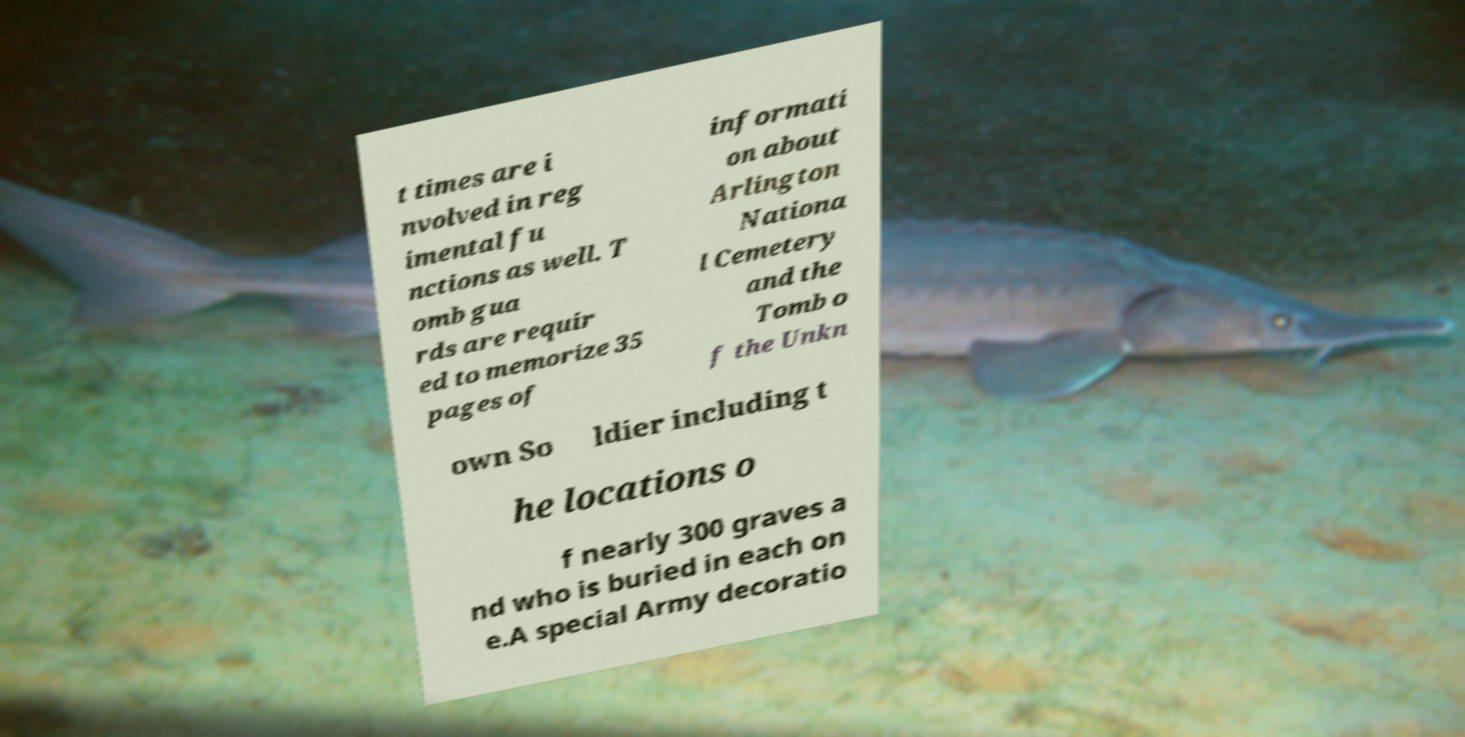Can you accurately transcribe the text from the provided image for me? t times are i nvolved in reg imental fu nctions as well. T omb gua rds are requir ed to memorize 35 pages of informati on about Arlington Nationa l Cemetery and the Tomb o f the Unkn own So ldier including t he locations o f nearly 300 graves a nd who is buried in each on e.A special Army decoratio 